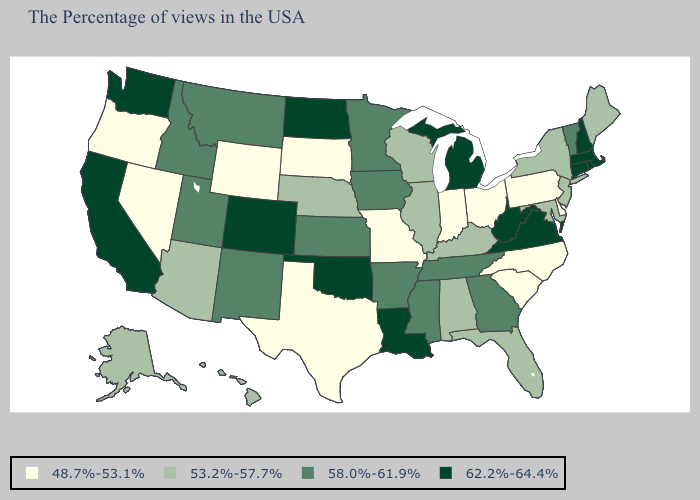What is the lowest value in the USA?
Short answer required. 48.7%-53.1%. Which states have the lowest value in the USA?
Be succinct. Delaware, Pennsylvania, North Carolina, South Carolina, Ohio, Indiana, Missouri, Texas, South Dakota, Wyoming, Nevada, Oregon. Does Texas have the highest value in the USA?
Quick response, please. No. What is the value of Connecticut?
Write a very short answer. 62.2%-64.4%. Name the states that have a value in the range 58.0%-61.9%?
Give a very brief answer. Vermont, Georgia, Tennessee, Mississippi, Arkansas, Minnesota, Iowa, Kansas, New Mexico, Utah, Montana, Idaho. Name the states that have a value in the range 53.2%-57.7%?
Answer briefly. Maine, New York, New Jersey, Maryland, Florida, Kentucky, Alabama, Wisconsin, Illinois, Nebraska, Arizona, Alaska, Hawaii. Does Michigan have the highest value in the MidWest?
Give a very brief answer. Yes. What is the value of California?
Quick response, please. 62.2%-64.4%. What is the value of Massachusetts?
Concise answer only. 62.2%-64.4%. Name the states that have a value in the range 58.0%-61.9%?
Write a very short answer. Vermont, Georgia, Tennessee, Mississippi, Arkansas, Minnesota, Iowa, Kansas, New Mexico, Utah, Montana, Idaho. Which states have the highest value in the USA?
Answer briefly. Massachusetts, Rhode Island, New Hampshire, Connecticut, Virginia, West Virginia, Michigan, Louisiana, Oklahoma, North Dakota, Colorado, California, Washington. What is the value of Michigan?
Answer briefly. 62.2%-64.4%. Name the states that have a value in the range 48.7%-53.1%?
Answer briefly. Delaware, Pennsylvania, North Carolina, South Carolina, Ohio, Indiana, Missouri, Texas, South Dakota, Wyoming, Nevada, Oregon. Does Wyoming have the lowest value in the West?
Answer briefly. Yes. Which states have the highest value in the USA?
Keep it brief. Massachusetts, Rhode Island, New Hampshire, Connecticut, Virginia, West Virginia, Michigan, Louisiana, Oklahoma, North Dakota, Colorado, California, Washington. 